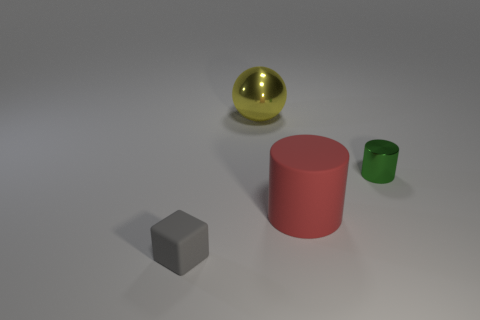Are the cube and the big red cylinder made of the same material?
Make the answer very short. Yes. Is the number of large red cylinders in front of the gray rubber thing less than the number of big rubber things on the left side of the shiny cylinder?
Your answer should be compact. Yes. There is a metal object left of the shiny thing that is right of the large yellow shiny sphere; how many large things are in front of it?
Your response must be concise. 1. What color is the cylinder that is the same size as the block?
Provide a succinct answer. Green. Is there another big matte object that has the same shape as the green object?
Offer a very short reply. Yes. Is there a matte thing that is in front of the rubber object behind the rubber thing to the left of the large shiny thing?
Your response must be concise. Yes. The red rubber thing that is the same size as the sphere is what shape?
Provide a succinct answer. Cylinder. What is the color of the other metallic object that is the same shape as the large red thing?
Ensure brevity in your answer.  Green. What number of things are large yellow balls or small things?
Keep it short and to the point. 3. There is a big thing that is in front of the green thing; is its shape the same as the metal object that is right of the large matte cylinder?
Provide a succinct answer. Yes. 